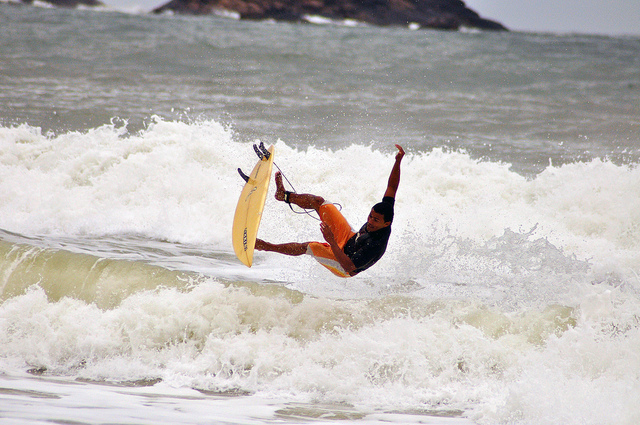What maneuver is the surfer performing in this image? The surfer appears to be performing an aerial trick, possibly a kick out or an airborne maneuver to navigate the wave. 